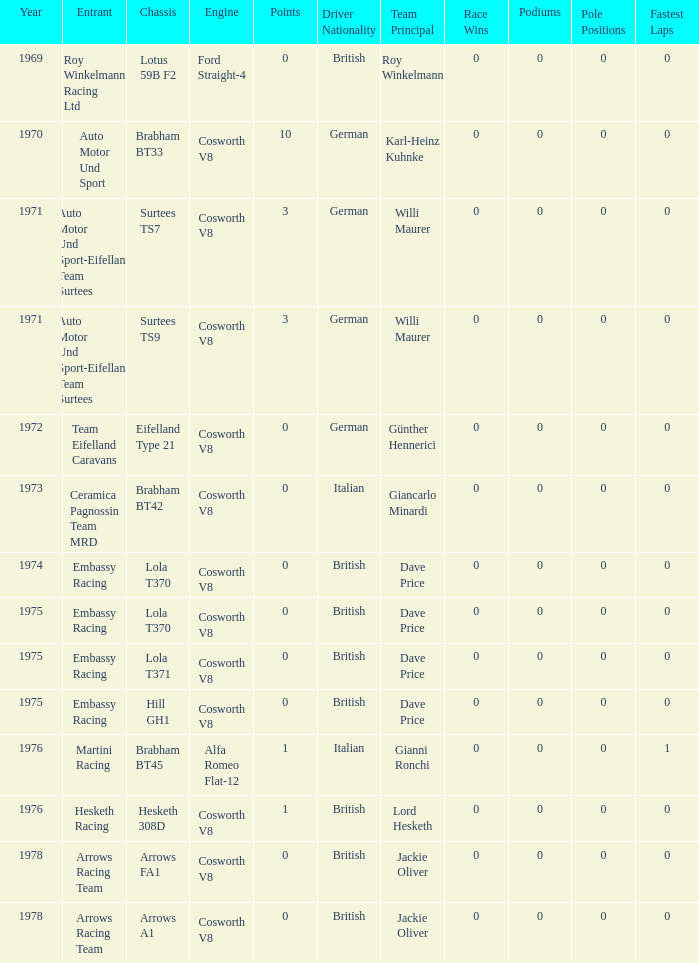Who was the entrant in 1971? Auto Motor Und Sport-Eifelland Team Surtees, Auto Motor Und Sport-Eifelland Team Surtees. 